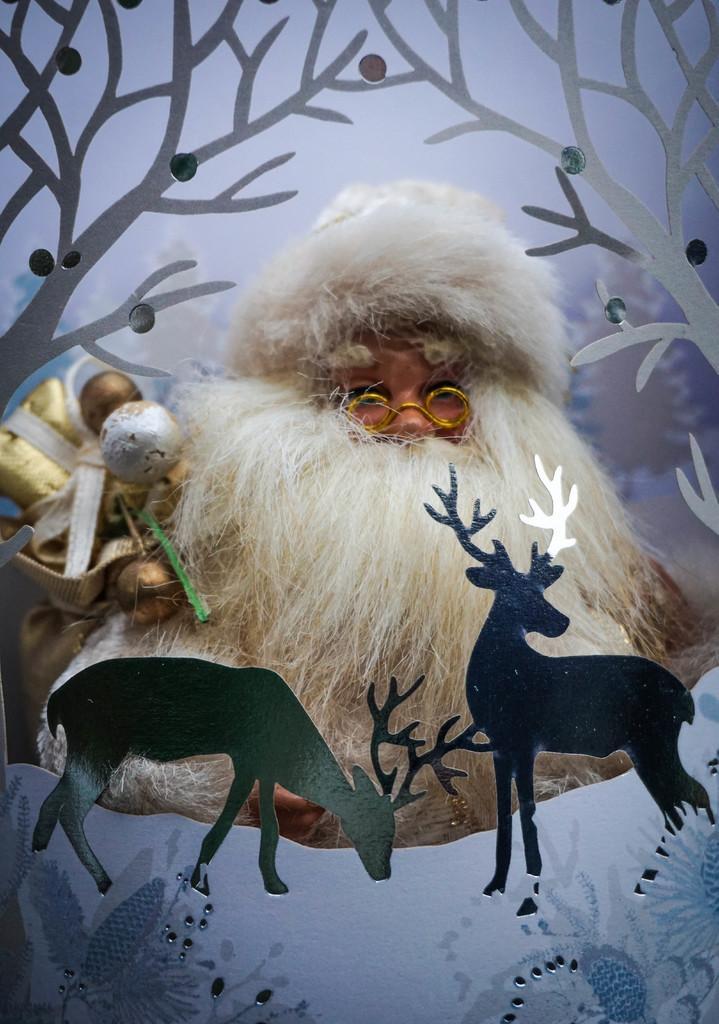How would you summarize this image in a sentence or two? In this image in the center there is one person who is standing and he is wearing a bag, and in the foreground there are some toys and in the background there is an animation. 